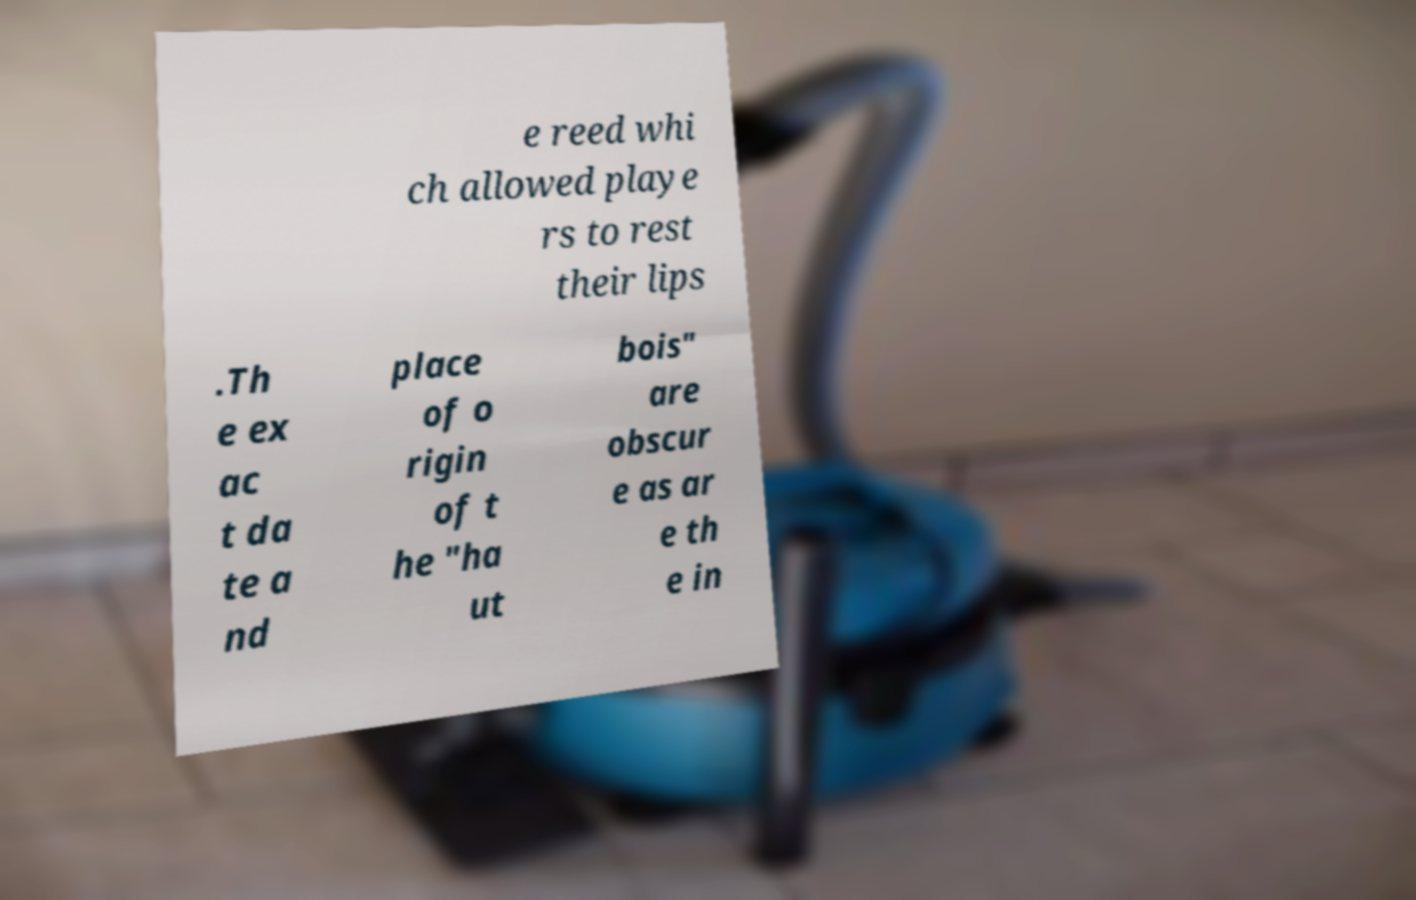Can you read and provide the text displayed in the image?This photo seems to have some interesting text. Can you extract and type it out for me? e reed whi ch allowed playe rs to rest their lips .Th e ex ac t da te a nd place of o rigin of t he "ha ut bois" are obscur e as ar e th e in 